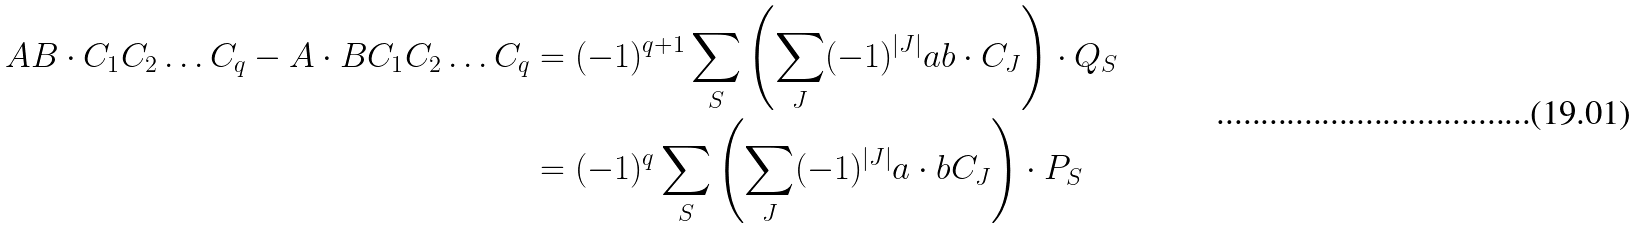<formula> <loc_0><loc_0><loc_500><loc_500>A B \cdot C _ { 1 } C _ { 2 } \dots C _ { q } - A \cdot B C _ { 1 } C _ { 2 } \dots C _ { q } & = ( - 1 ) ^ { q + 1 } \sum _ { S } \left ( \sum _ { J } ( - 1 ) ^ { | J | } a b \cdot C _ { J } \right ) \cdot Q _ { S } \\ & = ( - 1 ) ^ { q } \sum _ { S } \left ( \sum _ { J } ( - 1 ) ^ { | J | } a \cdot b C _ { J } \right ) \cdot P _ { S }</formula> 